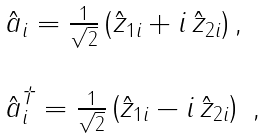<formula> <loc_0><loc_0><loc_500><loc_500>\begin{array} { l } \hat { a } _ { i } = \frac { 1 } { \sqrt { 2 } } \left ( \hat { z } _ { 1 i } + i \, \hat { z } _ { 2 i } \right ) , \\ \\ \hat { a } _ { i } ^ { \dagger } = \frac { 1 } { \sqrt { 2 } } \left ( \hat { z } _ { 1 i } - i \, \hat { z } _ { 2 i } \right ) \ , \end{array}</formula> 